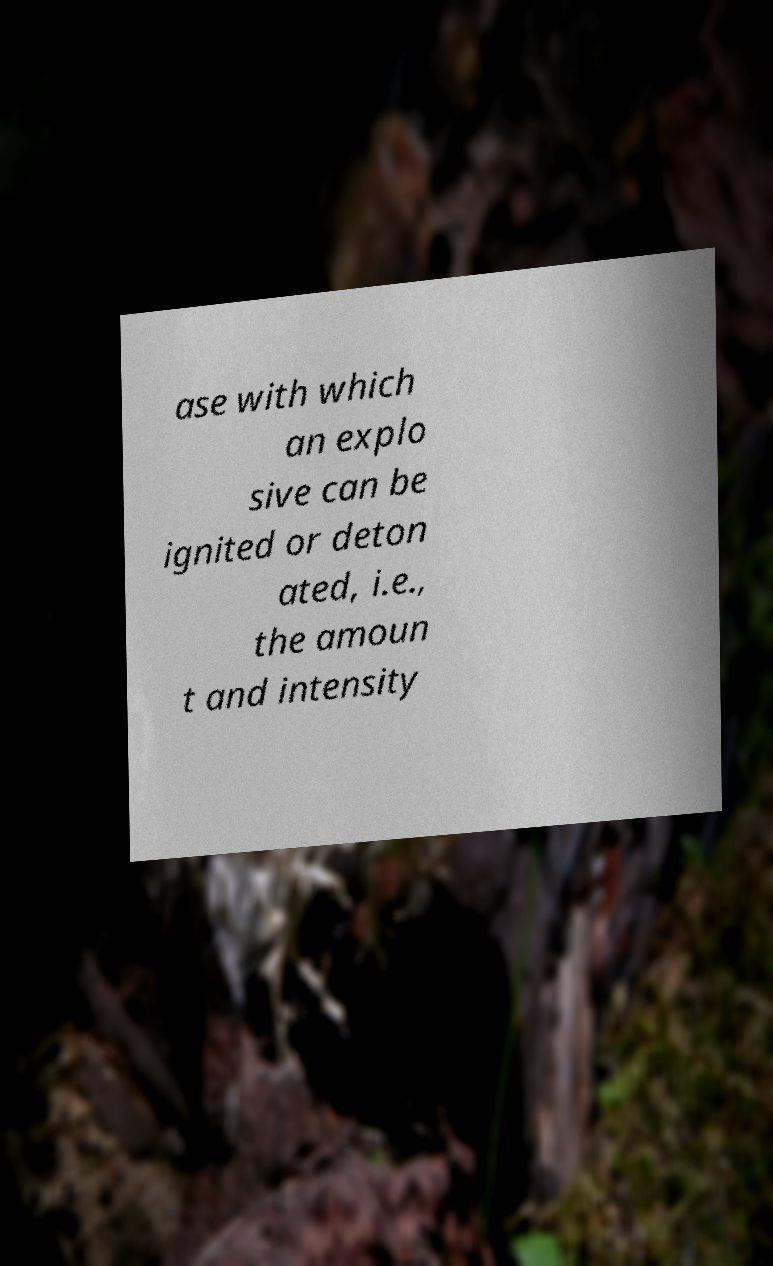For documentation purposes, I need the text within this image transcribed. Could you provide that? ase with which an explo sive can be ignited or deton ated, i.e., the amoun t and intensity 